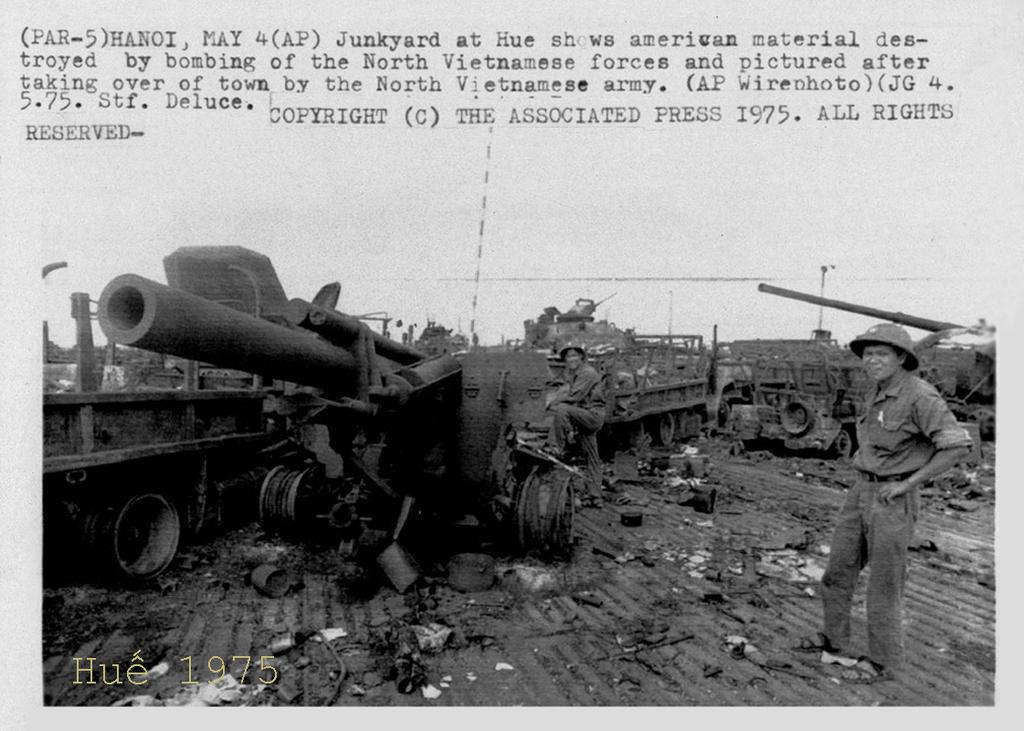<image>
Offer a succinct explanation of the picture presented. A group of brave soldiers around military equipment dated May 4th 1975. 